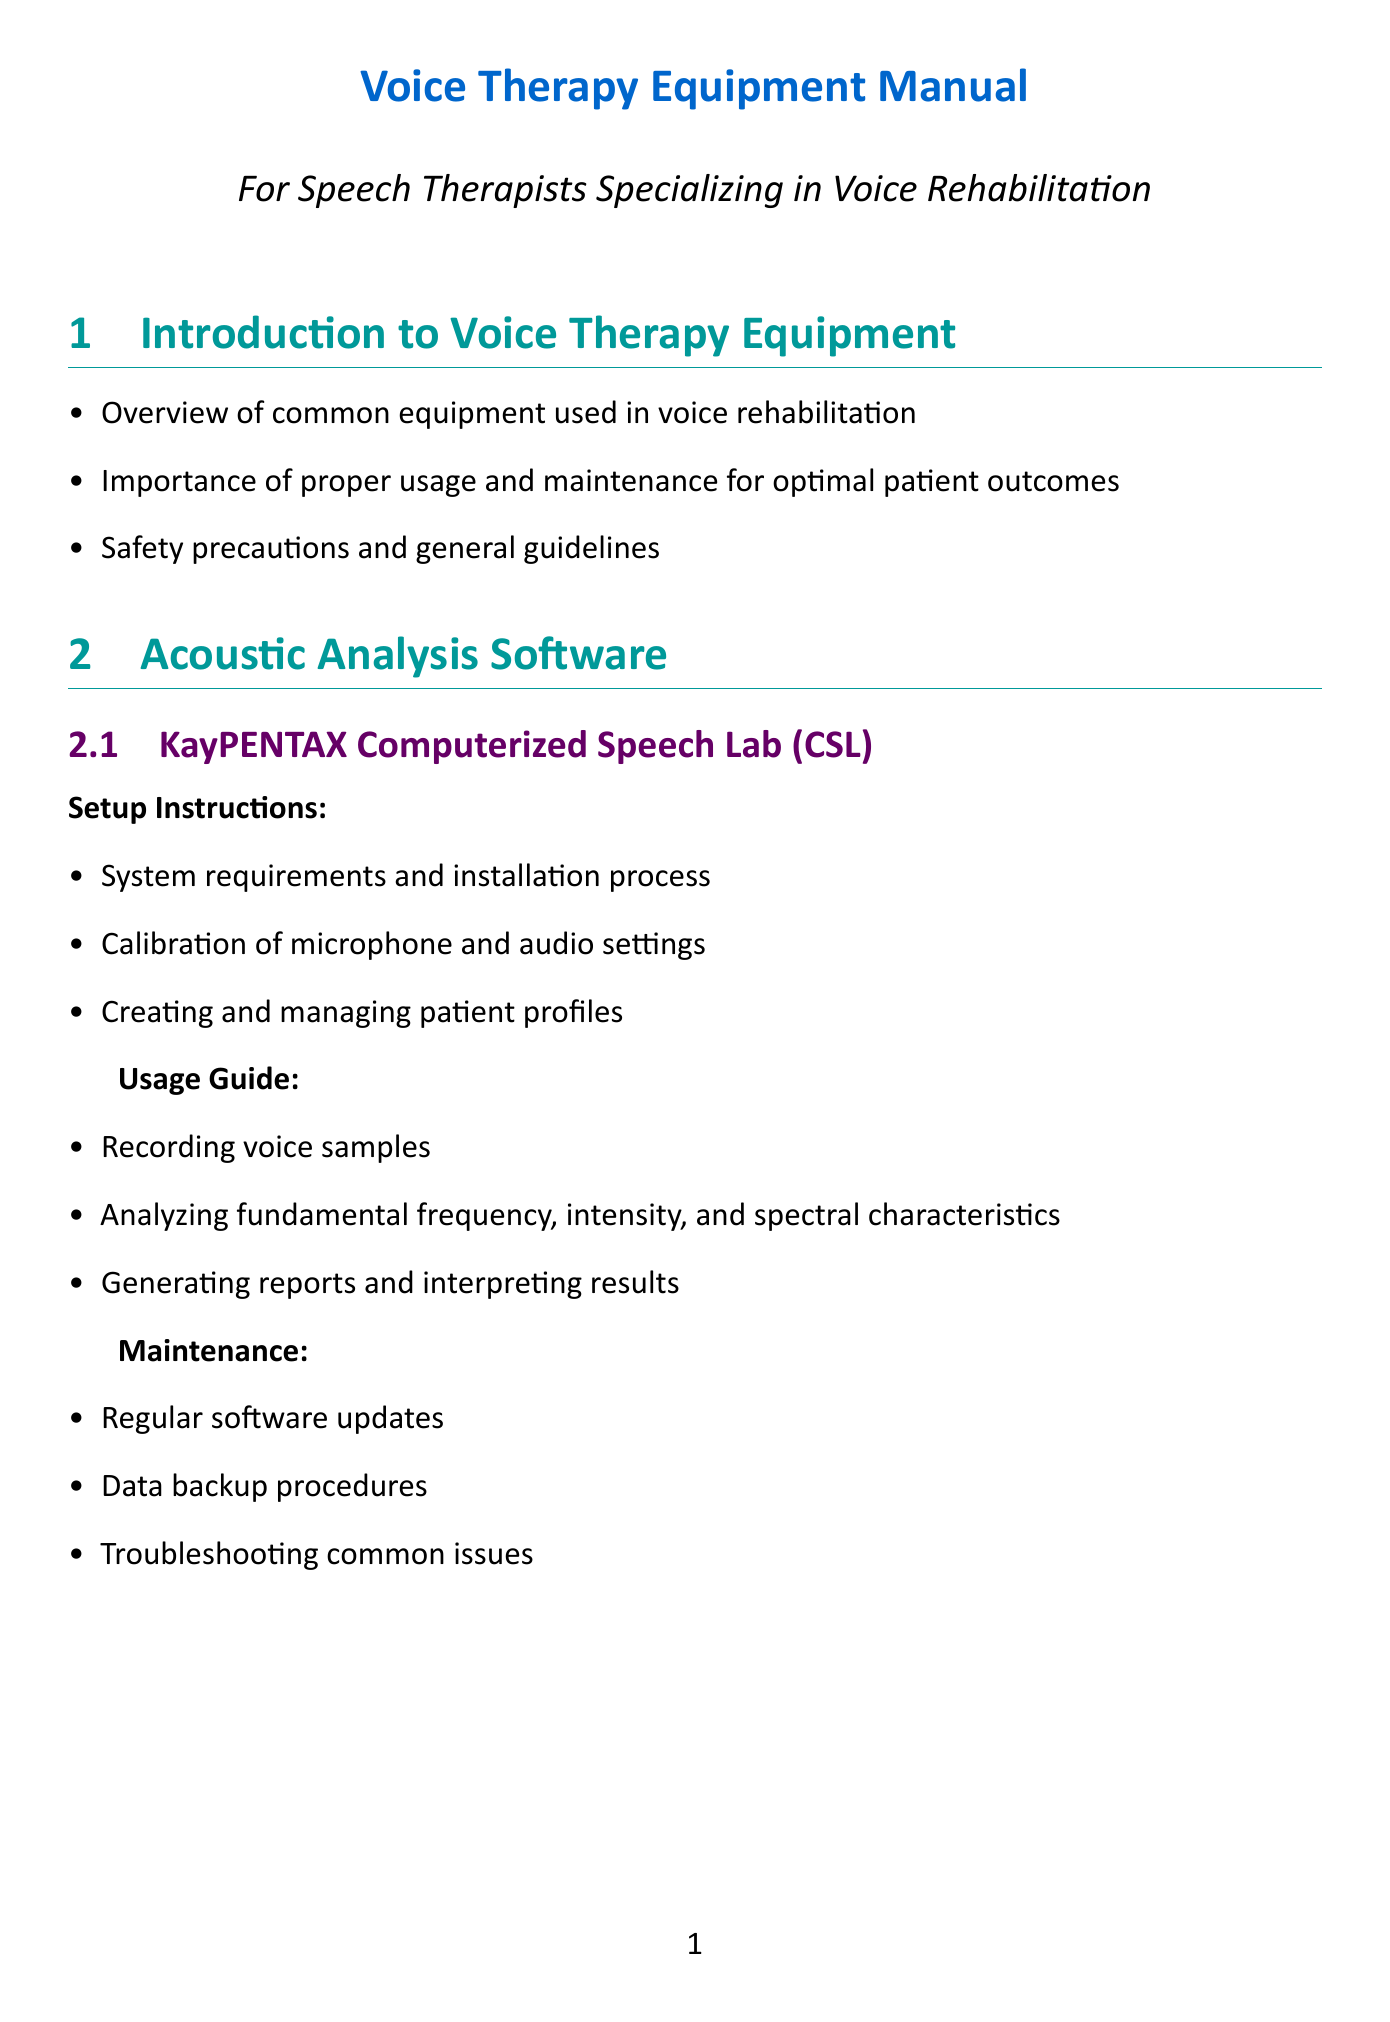What is the title of the manual? The title of the manual is located at the beginning of the document, providing a brief description of its purpose.
Answer: Voice Therapy Equipment Manual What is the first item listed under safety precautions? The first item under safety precautions is mentioned in the overview section, highlighting the importance of safety in equipment use.
Answer: Importance of proper usage and maintenance What software is mentioned for acoustic analysis? The document lists specific software used for acoustic analysis within its section on Acoustic Analysis Software.
Answer: KayPENTAX Computerized Speech Lab What is a key maintenance task for the KayPENTAX Computerized Speech Lab? The maintenance section details tasks that should be performed regularly to ensure optimal usage of the software.
Answer: Regular software updates How many laryngeal imaging devices are discussed? The document outlines multiple devices within the Laryngeal Imaging Devices section.
Answer: Two What is one of the usage instructions for the Rothenberg Mask? The usage instructions are provided to ensure proper application and effectiveness of the device during therapy.
Answer: Proper fitting and sealing techniques Which device requires sterilization before use? The setup instructions outline necessary preparations before using the imaging device, emphasizing patient safety.
Answer: PENTAX Medical VNL-1190STK Video Nasolaryngoscope What should you do when troubleshooting software problems? The document includes a section dedicated to resolving common issues and guidance for further support.
Answer: Contact manufacturer support What are the home care instructions intended for? The last section addresses resources and materials for patients, describing their purpose related to rehabilitation.
Answer: Voice rehabilitation 